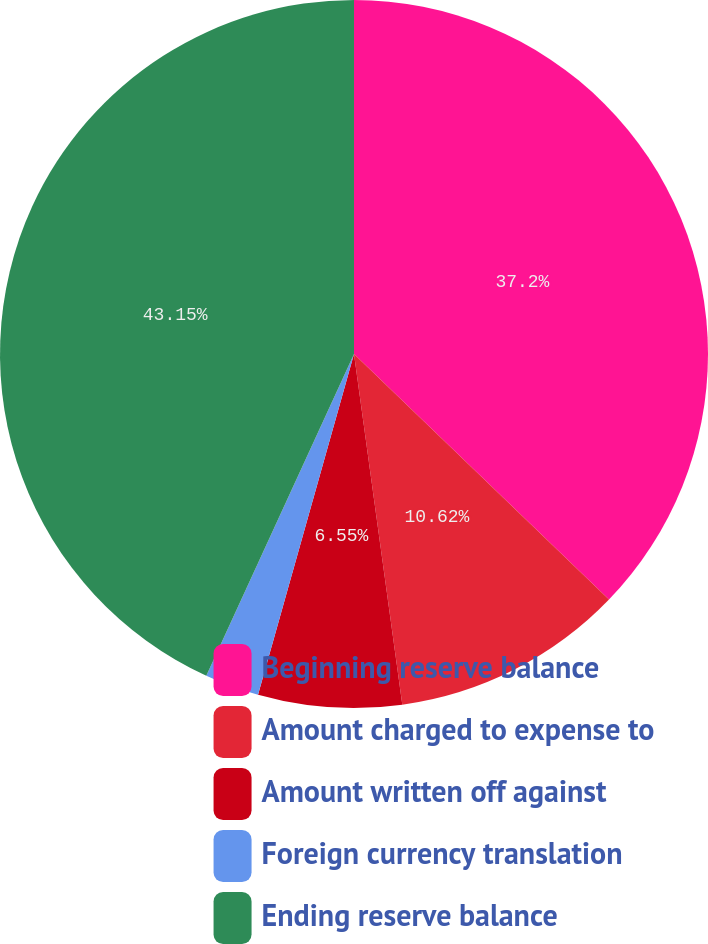<chart> <loc_0><loc_0><loc_500><loc_500><pie_chart><fcel>Beginning reserve balance<fcel>Amount charged to expense to<fcel>Amount written off against<fcel>Foreign currency translation<fcel>Ending reserve balance<nl><fcel>37.2%<fcel>10.62%<fcel>6.55%<fcel>2.48%<fcel>43.15%<nl></chart> 